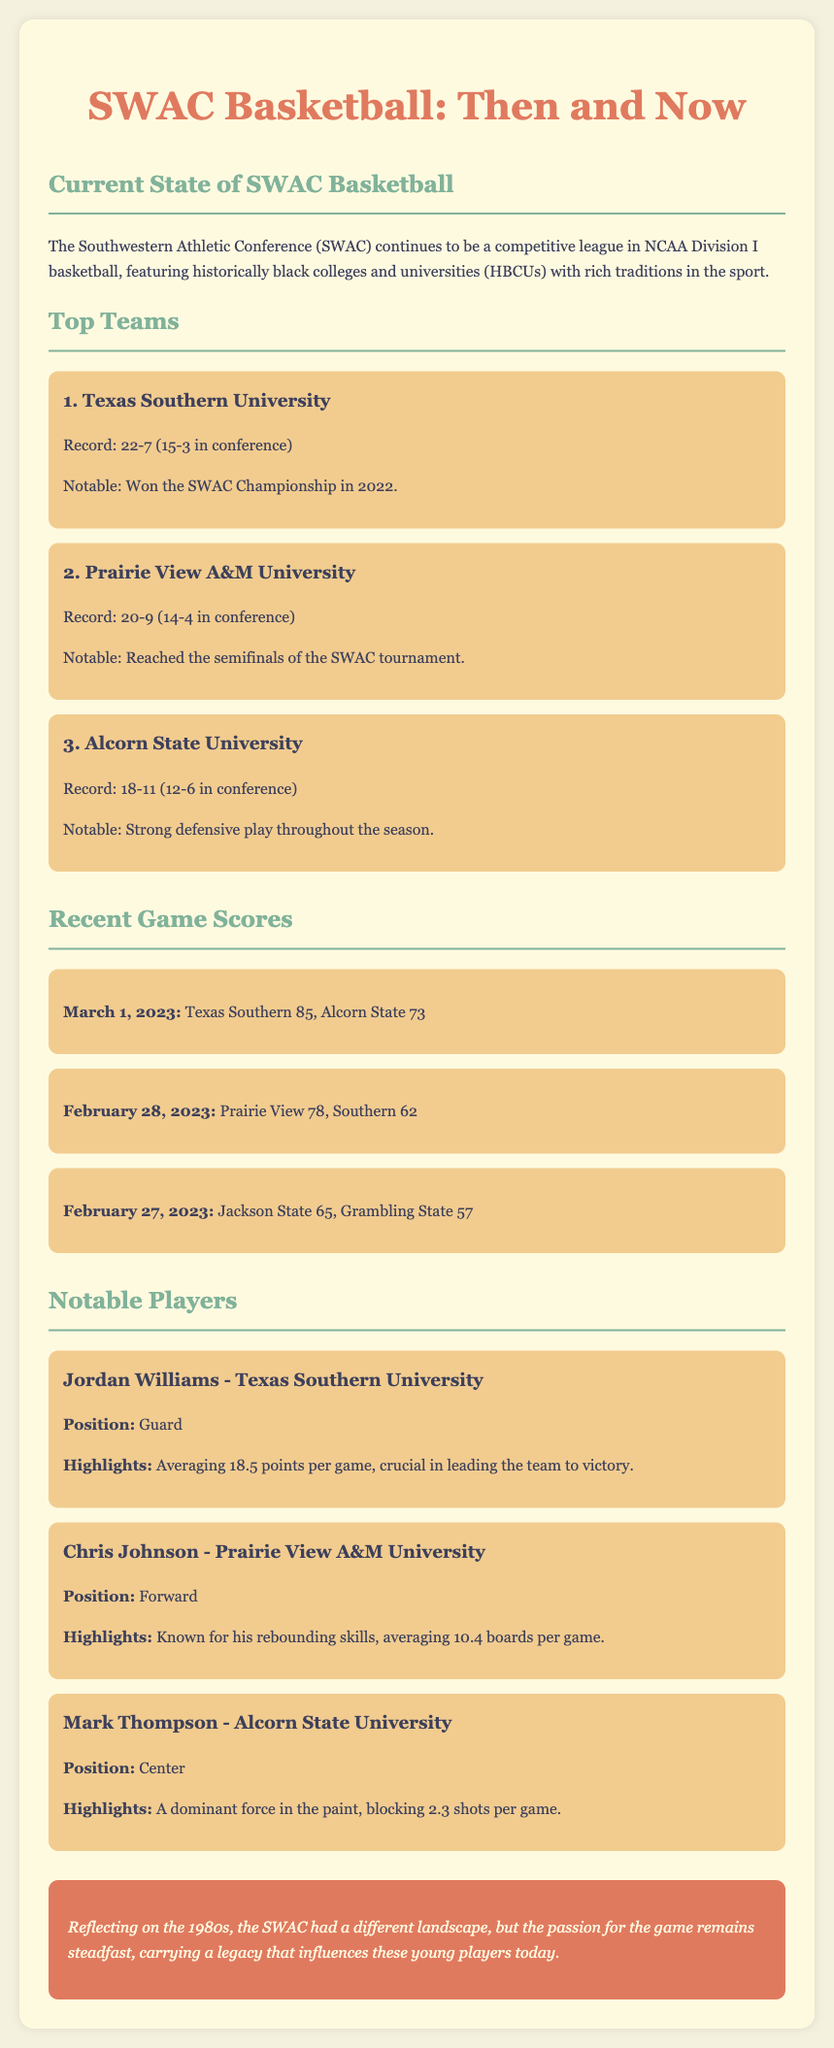what is the record of Texas Southern University? The record is provided in the team rankings section, showing Texas Southern's performance in the season.
Answer: 22-7 who reached the semifinals of the SWAC tournament? The notable information is given for Prairie View A&M University in the team rankings section.
Answer: Prairie View A&M University what was the score of the game between Texas Southern and Alcorn State on March 1, 2023? The score is found in the recent game scores section, detailing the outcome of that specific game.
Answer: 85, 73 how many points per game is Jordan Williams averaging? Jordan Williams' performance stat is mentioned in the player profiles section, specifically under his highlights.
Answer: 18.5 points who is known for rebounding skills? This information is found in the player profiles section, which highlights specific skills of individual players.
Answer: Chris Johnson which team has a strong defensive play throughout the season? This is highlighted in the team rankings section, under Alcorn State University's profile.
Answer: Alcorn State University how many boards per game is Chris Johnson averaging? Chris Johnson's statistical performance is detailed in his player profile, focusing on his rebounding.
Answer: 10.4 boards what position does Mark Thompson play? The position of Mark Thompson is explicitly stated in his player profile in the document.
Answer: Center what color scheme is used for the document's background? The background color is mentioned in the style section of the code, describing the overall aesthetic of the document.
Answer: #f4f1de 